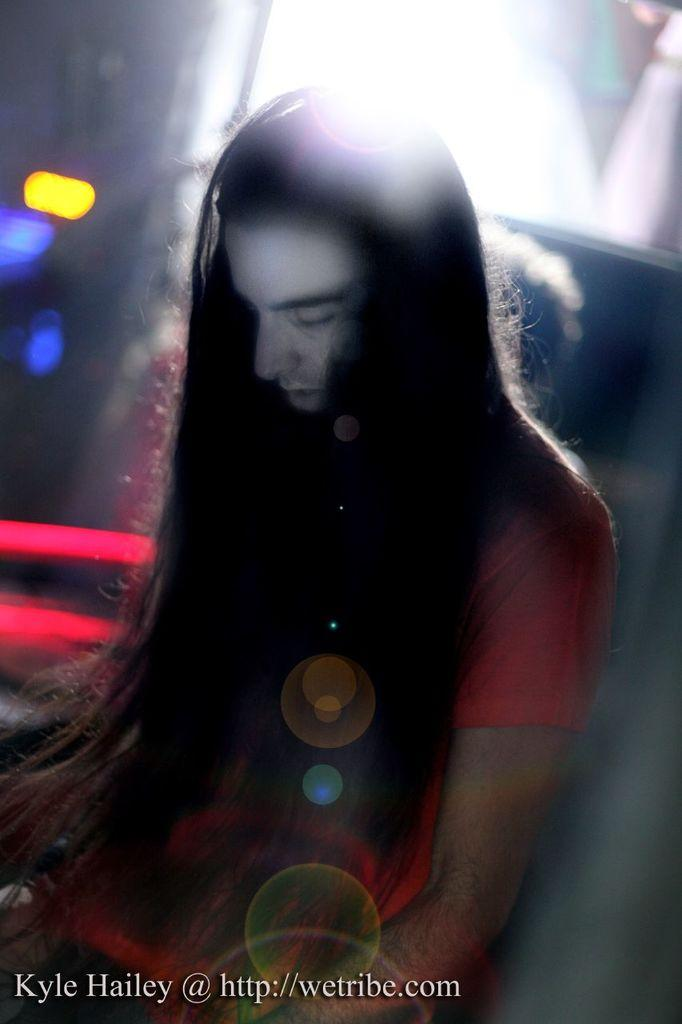What can be said about the nature of the image? The image is edited. Who is present in the image? There is a man with long hair in the image. What can be seen in the image besides the man? There are lights visible in the image. Where is the text located in the image? There is text in the bottom left corner of the image. What type of lumber is the man using to rake the leaves in the image? There is no lumber or rake present in the image; it only features a man with long hair and lights. How does the man's cast affect his ability to cast a fishing line in the image? There is no mention of a cast or fishing line in the image; the man has long hair and is surrounded by lights. 